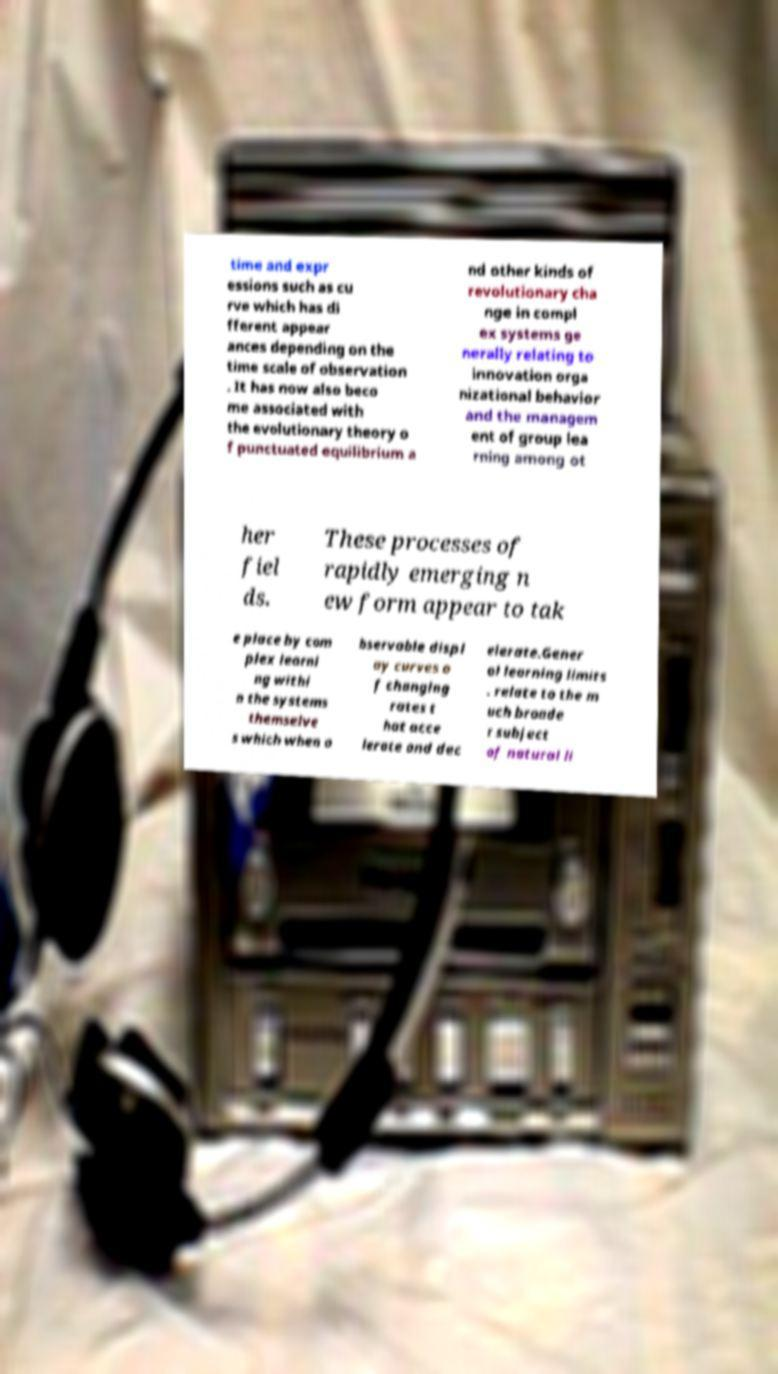I need the written content from this picture converted into text. Can you do that? time and expr essions such as cu rve which has di fferent appear ances depending on the time scale of observation . It has now also beco me associated with the evolutionary theory o f punctuated equilibrium a nd other kinds of revolutionary cha nge in compl ex systems ge nerally relating to innovation orga nizational behavior and the managem ent of group lea rning among ot her fiel ds. These processes of rapidly emerging n ew form appear to tak e place by com plex learni ng withi n the systems themselve s which when o bservable displ ay curves o f changing rates t hat acce lerate and dec elerate.Gener al learning limits . relate to the m uch broade r subject of natural li 